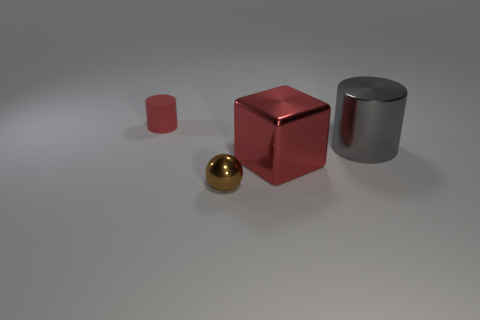Is there anything in the image that indicates a sense of scale? No direct indicators of scale, such as a known object or ruler, are present in the image. However, the relative sizes of the objects to each other can suggest a sense of scale — the cube, cylinder, and smaller cuboid appear proportionate to common real-world objects that could be held in one's hand, whereas the tiny ball, in comparison, would likely fit between two fingers. 